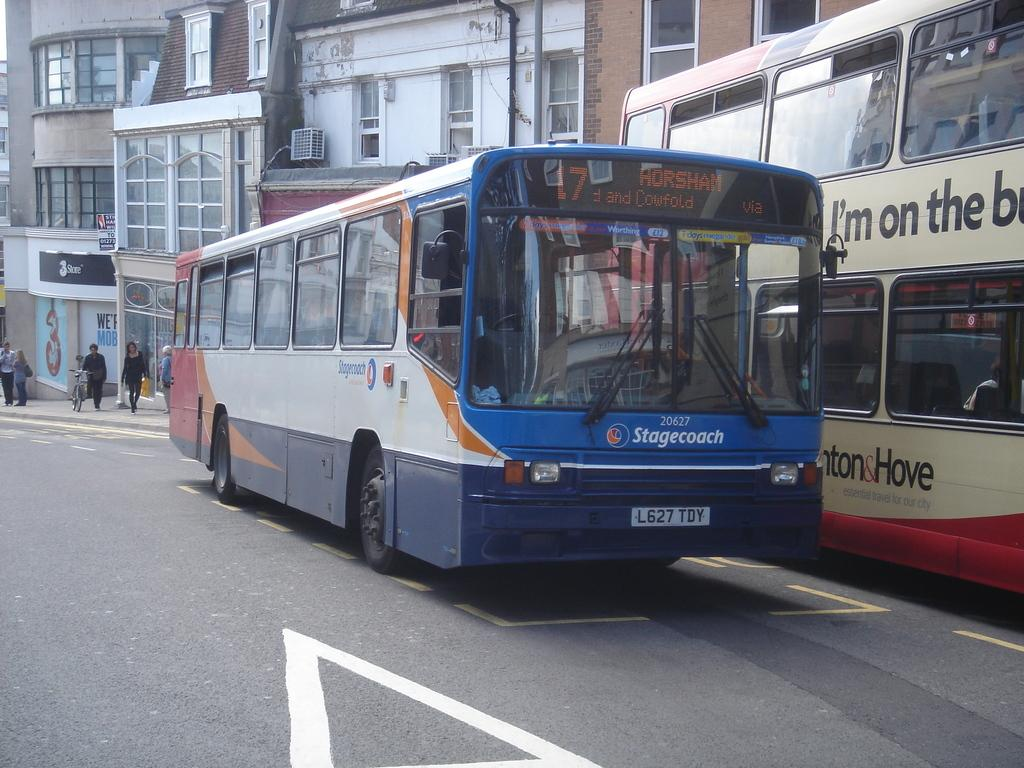<image>
Give a short and clear explanation of the subsequent image. Bus 17 passes another bus on its way to Horsham. 